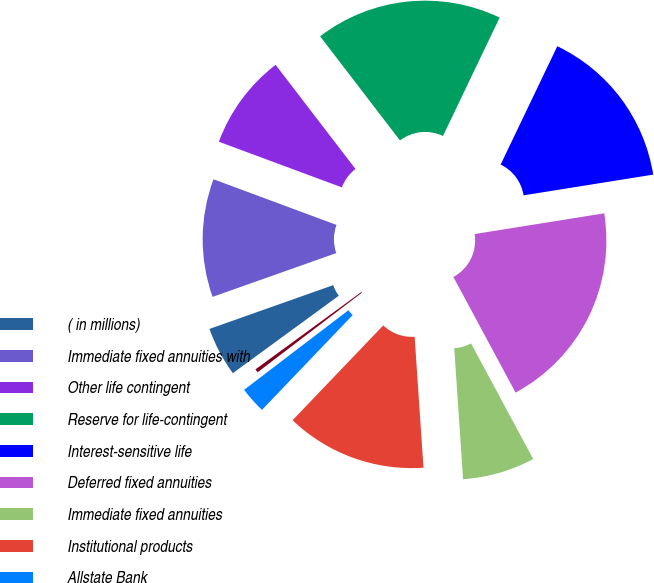<chart> <loc_0><loc_0><loc_500><loc_500><pie_chart><fcel>( in millions)<fcel>Immediate fixed annuities with<fcel>Other life contingent<fcel>Reserve for life-contingent<fcel>Interest-sensitive life<fcel>Deferred fixed annuities<fcel>Immediate fixed annuities<fcel>Institutional products<fcel>Allstate Bank<fcel>Market value adjustments<nl><fcel>4.63%<fcel>11.07%<fcel>8.93%<fcel>17.52%<fcel>15.37%<fcel>19.67%<fcel>6.78%<fcel>13.22%<fcel>2.48%<fcel>0.33%<nl></chart> 